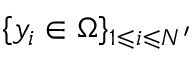Convert formula to latex. <formula><loc_0><loc_0><loc_500><loc_500>\{ y _ { i } \in \Omega \} _ { 1 \leqslant i \leqslant N ^ { \prime } }</formula> 